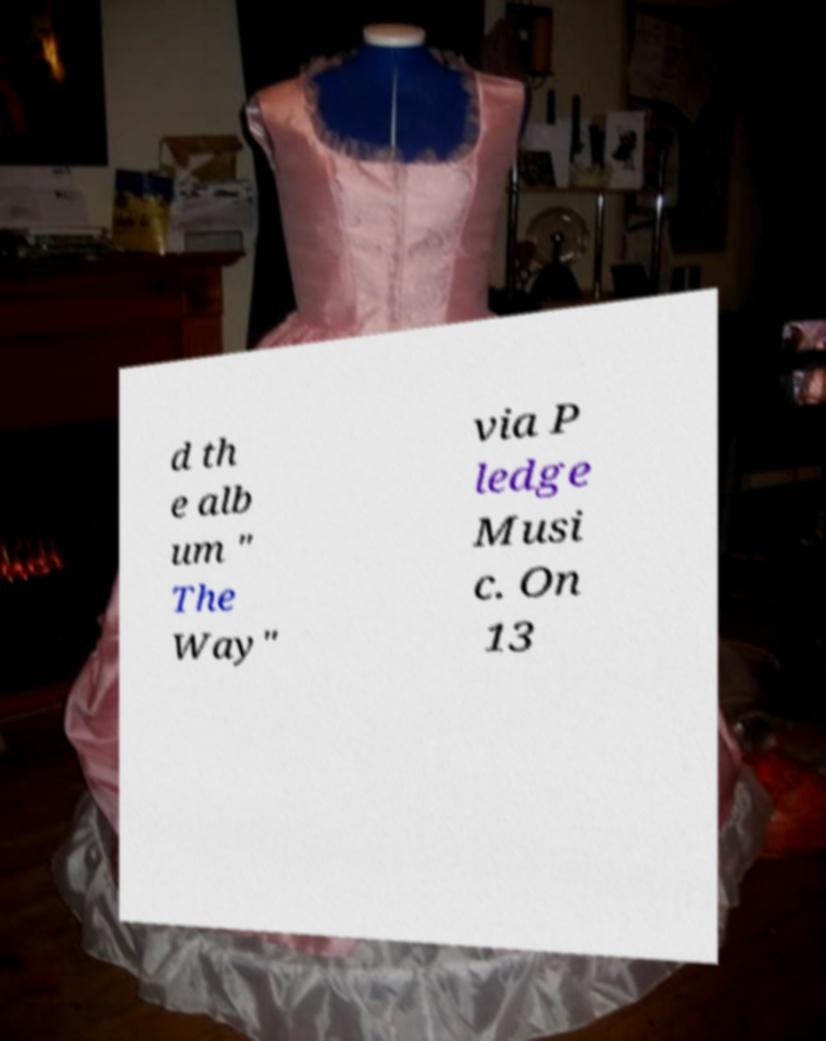There's text embedded in this image that I need extracted. Can you transcribe it verbatim? d th e alb um " The Way" via P ledge Musi c. On 13 